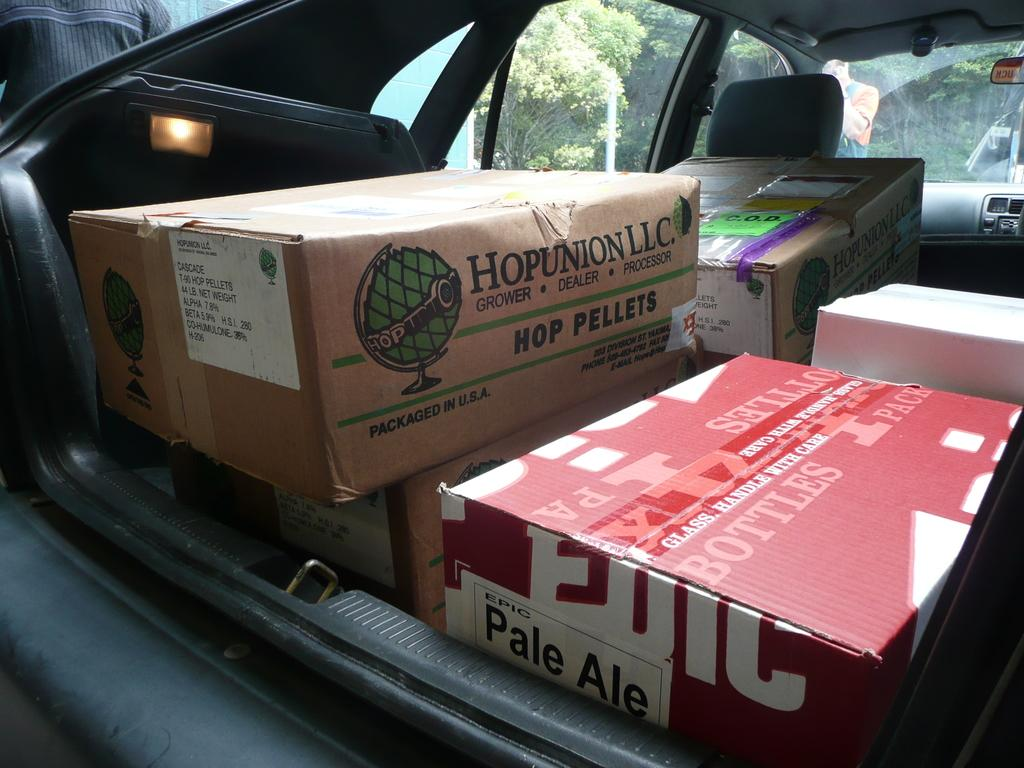What is the main subject in the foreground of the picture? There is a vehicle in the foreground of the picture. What can be seen inside the vehicle? There are boxes in the vehicle. Can you describe the people in the picture? There is a person on the left side of the picture and another person in the background of the picture. What is visible in the background of the picture? There is a wall and a pole in the background of the picture. What type of riddle is the person on the left side of the picture trying to solve in the image? There is no indication in the image that the person is trying to solve a riddle. Can you tell me how many toothbrushes are visible in the image? There are no toothbrushes present in the image. 